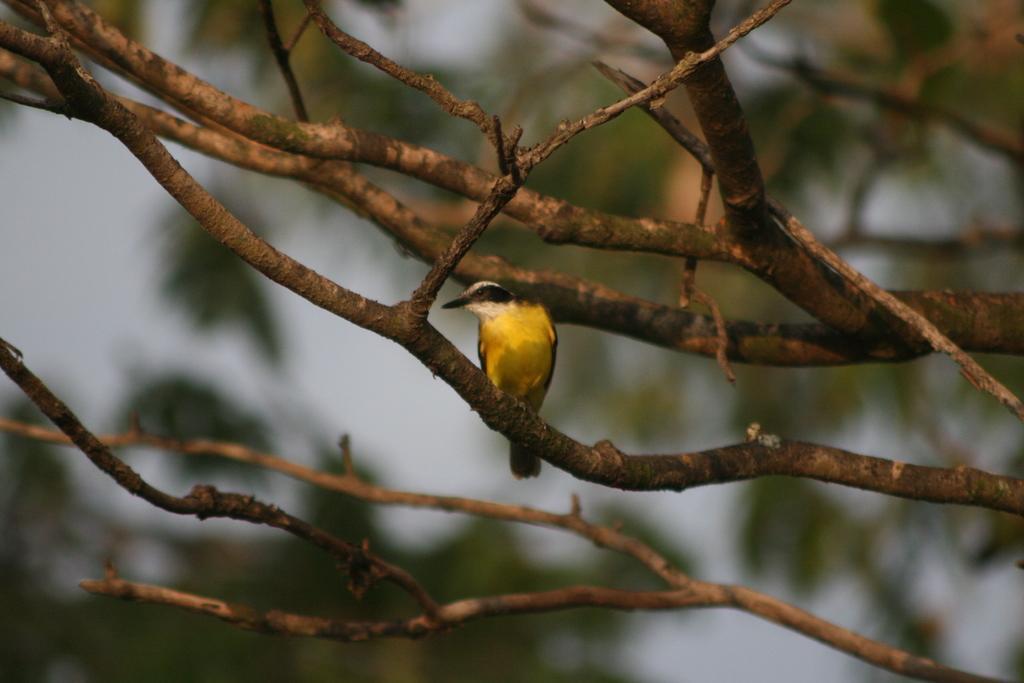In one or two sentences, can you explain what this image depicts? In this picture I can see number of branches and I see a bird on one of the branch and I see that it is blurred in the background. 